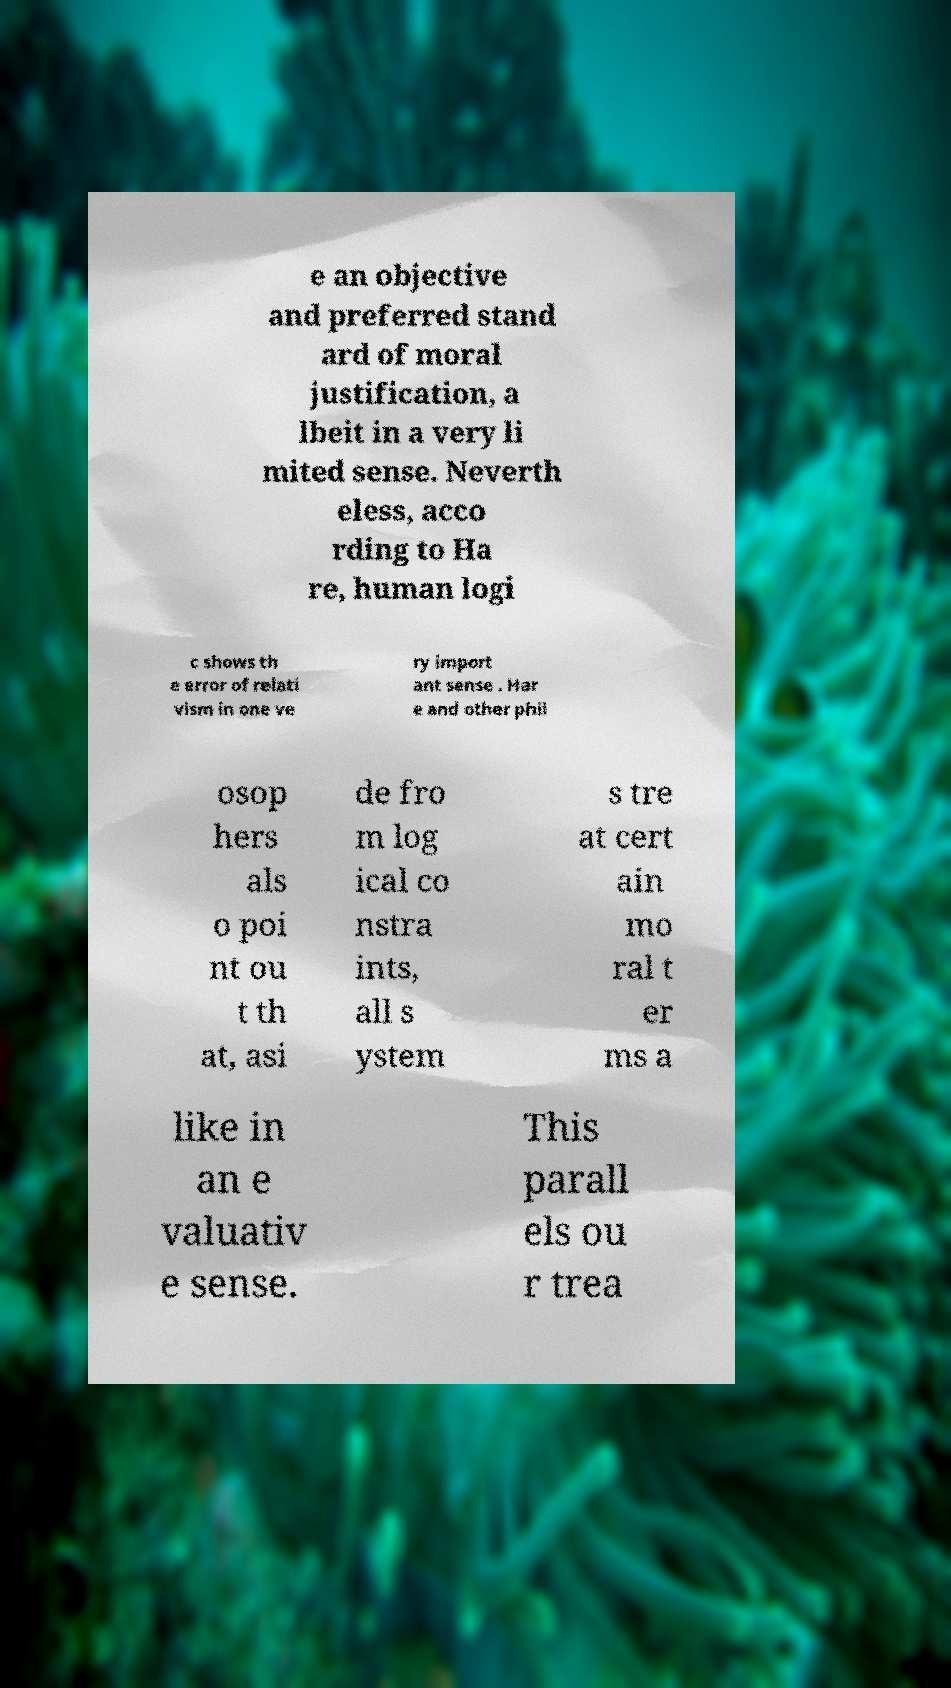Can you read and provide the text displayed in the image?This photo seems to have some interesting text. Can you extract and type it out for me? e an objective and preferred stand ard of moral justification, a lbeit in a very li mited sense. Neverth eless, acco rding to Ha re, human logi c shows th e error of relati vism in one ve ry import ant sense . Har e and other phil osop hers als o poi nt ou t th at, asi de fro m log ical co nstra ints, all s ystem s tre at cert ain mo ral t er ms a like in an e valuativ e sense. This parall els ou r trea 